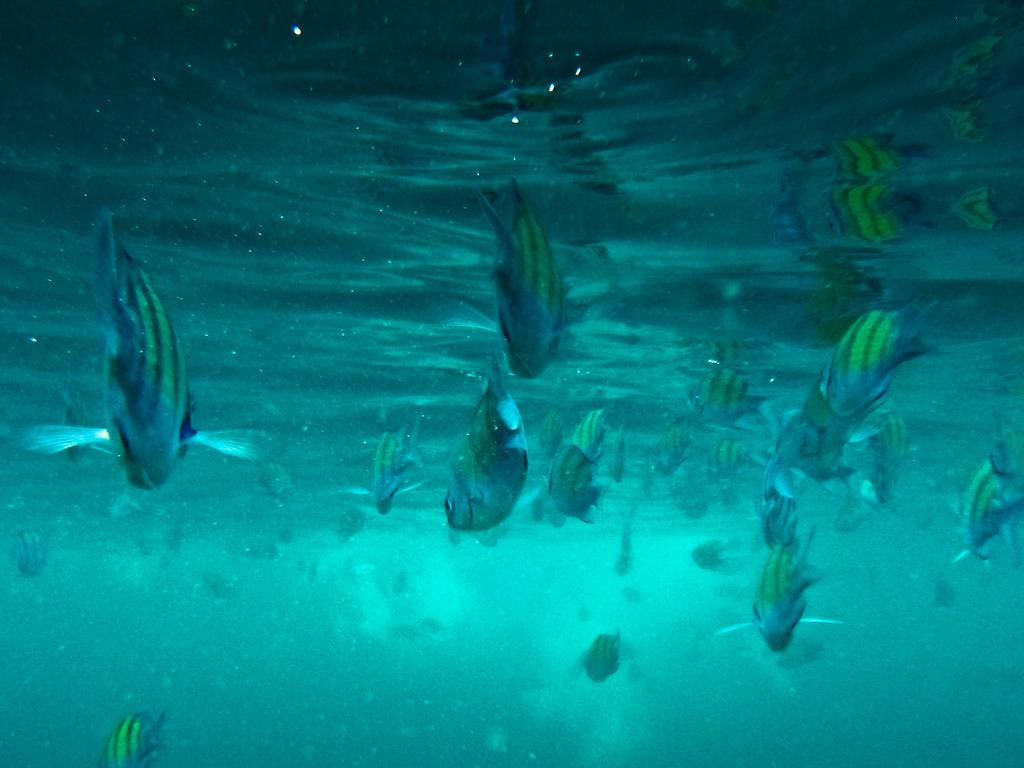What colors are the fishes in the image? The fishes in the image are silver and yellow in color. What is the environment in which the fishes are located? The fishes are in seawater. Can you read the writing on the back of the silver fish in the image? There is no writing present on the back of the silver fish in the image, as fish do not have the ability to have writing on their bodies. 